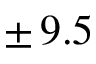Convert formula to latex. <formula><loc_0><loc_0><loc_500><loc_500>\pm \, 9 . 5</formula> 